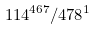Convert formula to latex. <formula><loc_0><loc_0><loc_500><loc_500>1 1 4 ^ { 4 6 7 } / 4 7 8 ^ { 1 }</formula> 